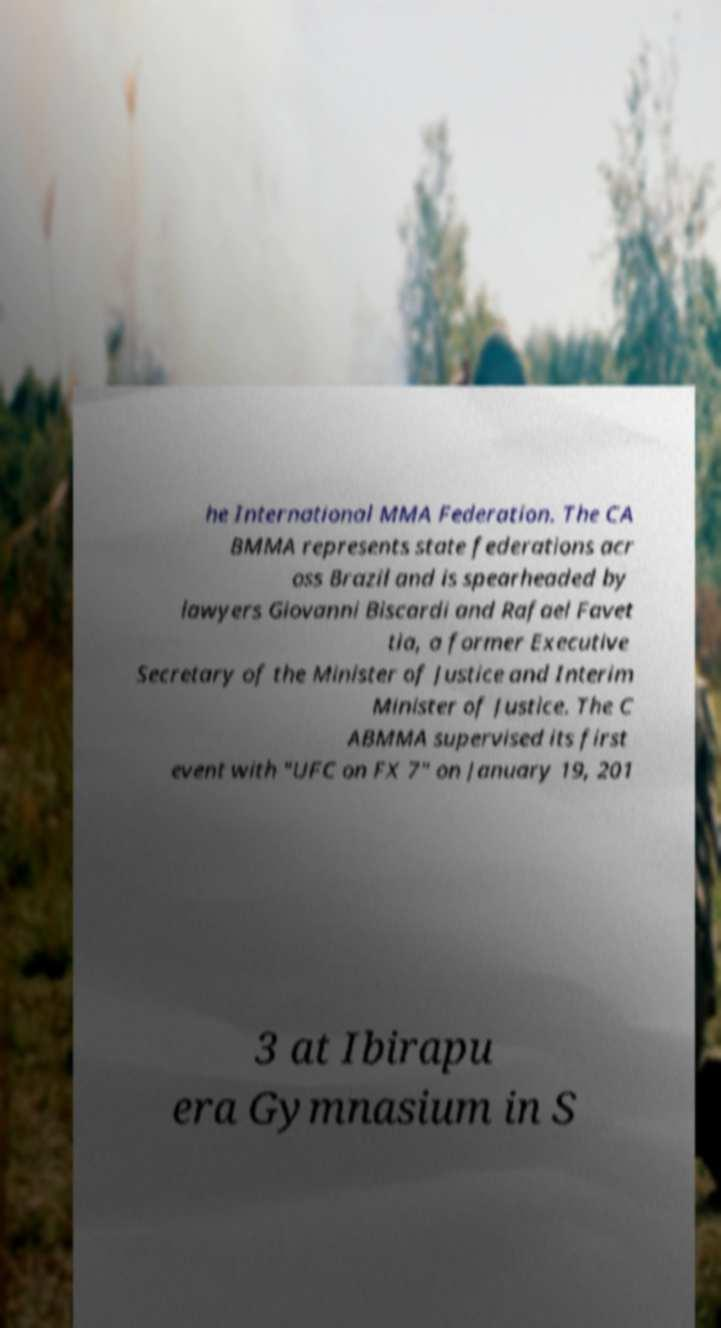For documentation purposes, I need the text within this image transcribed. Could you provide that? he International MMA Federation. The CA BMMA represents state federations acr oss Brazil and is spearheaded by lawyers Giovanni Biscardi and Rafael Favet tia, a former Executive Secretary of the Minister of Justice and Interim Minister of Justice. The C ABMMA supervised its first event with "UFC on FX 7" on January 19, 201 3 at Ibirapu era Gymnasium in S 